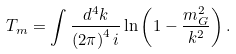Convert formula to latex. <formula><loc_0><loc_0><loc_500><loc_500>T _ { m } = \int \frac { d ^ { 4 } k } { \left ( 2 \pi \right ) ^ { 4 } i } \ln \left ( 1 - \frac { m ^ { 2 } _ { G } } { k ^ { 2 } } \right ) .</formula> 